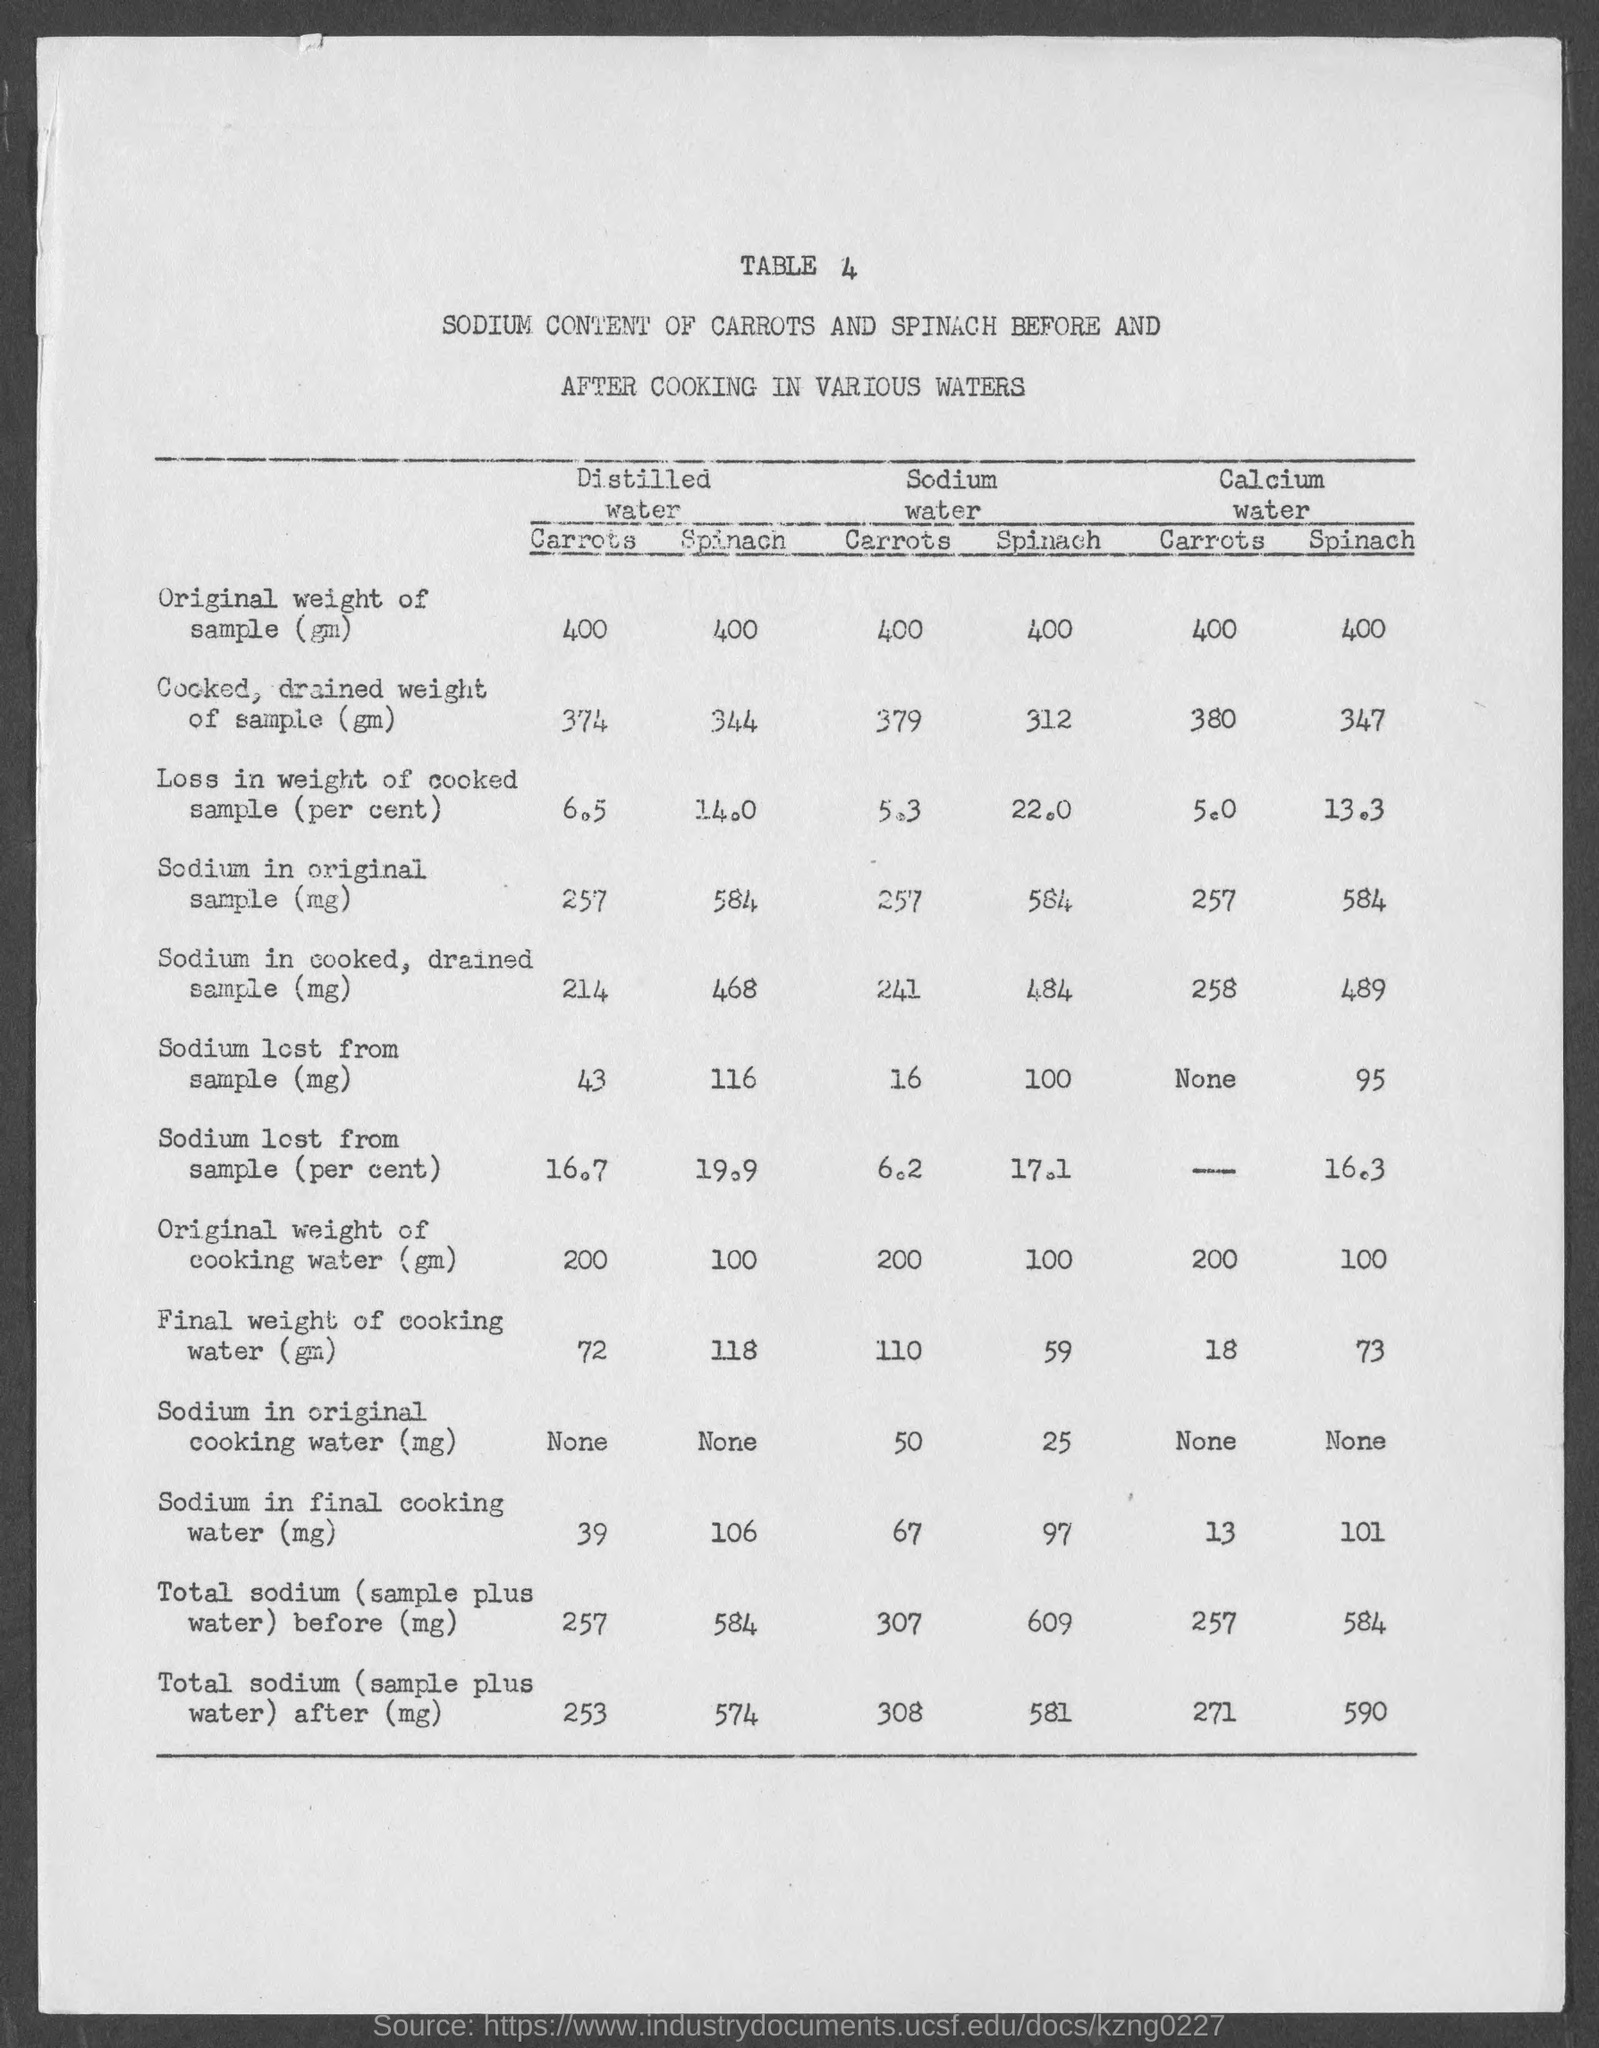What is the table no.?
Make the answer very short. 4. 